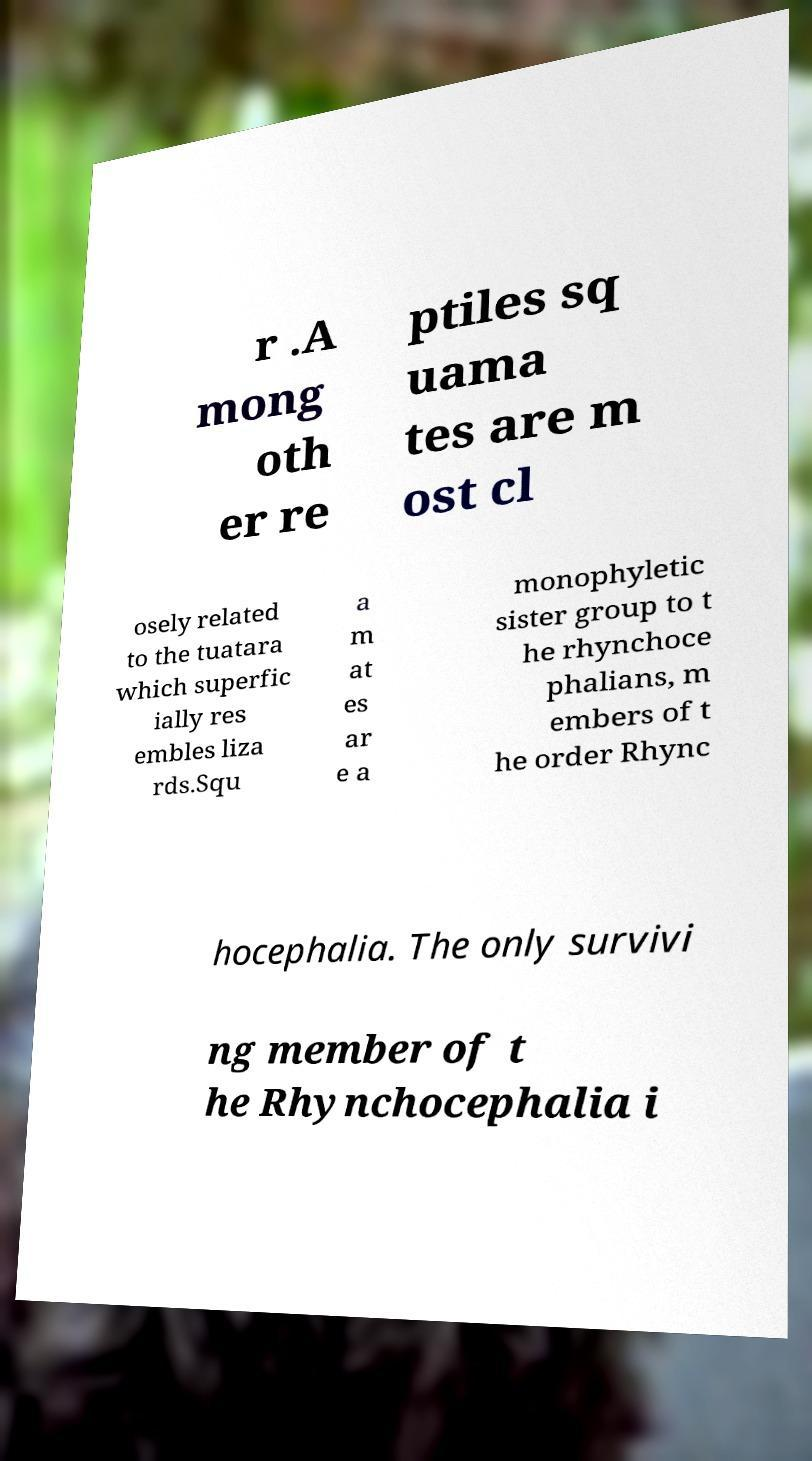What messages or text are displayed in this image? I need them in a readable, typed format. r .A mong oth er re ptiles sq uama tes are m ost cl osely related to the tuatara which superfic ially res embles liza rds.Squ a m at es ar e a monophyletic sister group to t he rhynchoce phalians, m embers of t he order Rhync hocephalia. The only survivi ng member of t he Rhynchocephalia i 